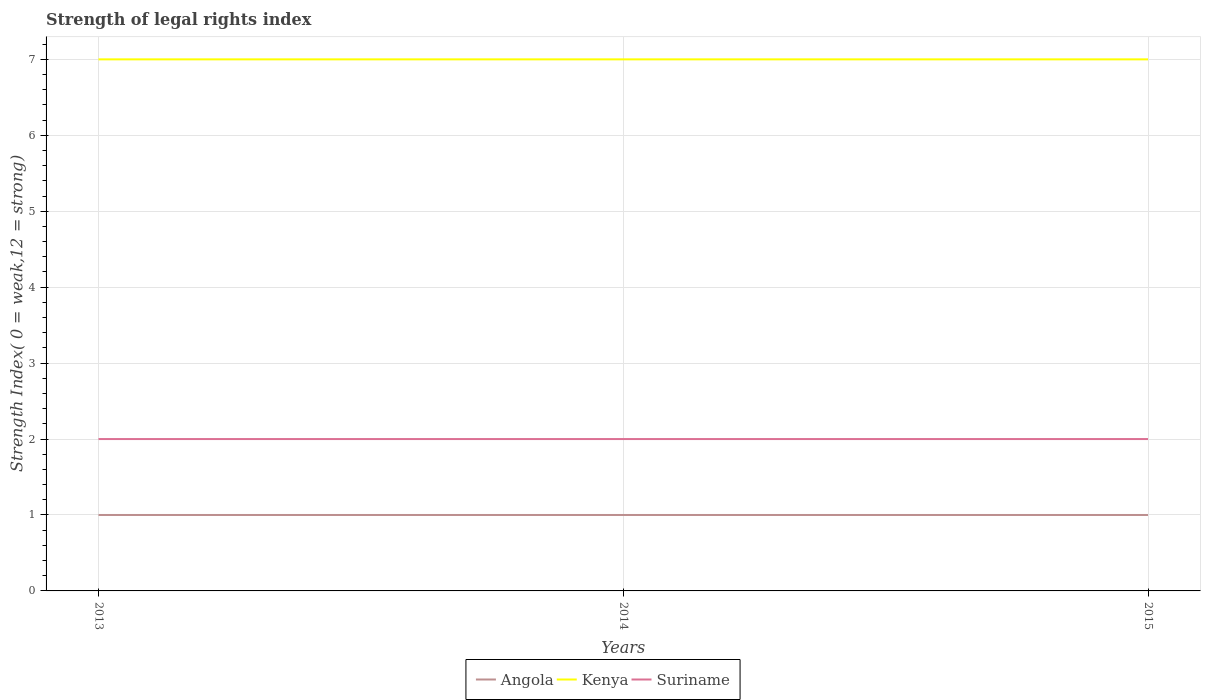How many different coloured lines are there?
Make the answer very short. 3. Does the line corresponding to Kenya intersect with the line corresponding to Suriname?
Keep it short and to the point. No. Across all years, what is the maximum strength index in Kenya?
Ensure brevity in your answer.  7. What is the total strength index in Kenya in the graph?
Make the answer very short. 0. Are the values on the major ticks of Y-axis written in scientific E-notation?
Your response must be concise. No. How many legend labels are there?
Provide a short and direct response. 3. How are the legend labels stacked?
Offer a very short reply. Horizontal. What is the title of the graph?
Your answer should be very brief. Strength of legal rights index. Does "Pakistan" appear as one of the legend labels in the graph?
Provide a succinct answer. No. What is the label or title of the X-axis?
Offer a very short reply. Years. What is the label or title of the Y-axis?
Provide a short and direct response. Strength Index( 0 = weak,12 = strong). What is the Strength Index( 0 = weak,12 = strong) in Kenya in 2013?
Offer a terse response. 7. What is the Strength Index( 0 = weak,12 = strong) of Suriname in 2013?
Ensure brevity in your answer.  2. What is the Strength Index( 0 = weak,12 = strong) in Angola in 2014?
Offer a terse response. 1. What is the Strength Index( 0 = weak,12 = strong) of Kenya in 2014?
Provide a succinct answer. 7. What is the Strength Index( 0 = weak,12 = strong) in Angola in 2015?
Provide a succinct answer. 1. What is the Strength Index( 0 = weak,12 = strong) in Kenya in 2015?
Offer a terse response. 7. Across all years, what is the maximum Strength Index( 0 = weak,12 = strong) in Angola?
Provide a succinct answer. 1. Across all years, what is the maximum Strength Index( 0 = weak,12 = strong) of Kenya?
Provide a succinct answer. 7. Across all years, what is the maximum Strength Index( 0 = weak,12 = strong) of Suriname?
Your answer should be very brief. 2. What is the total Strength Index( 0 = weak,12 = strong) in Angola in the graph?
Ensure brevity in your answer.  3. What is the total Strength Index( 0 = weak,12 = strong) of Kenya in the graph?
Ensure brevity in your answer.  21. What is the total Strength Index( 0 = weak,12 = strong) in Suriname in the graph?
Ensure brevity in your answer.  6. What is the difference between the Strength Index( 0 = weak,12 = strong) in Kenya in 2013 and that in 2014?
Give a very brief answer. 0. What is the difference between the Strength Index( 0 = weak,12 = strong) in Suriname in 2013 and that in 2014?
Keep it short and to the point. 0. What is the difference between the Strength Index( 0 = weak,12 = strong) of Suriname in 2013 and that in 2015?
Offer a terse response. 0. What is the difference between the Strength Index( 0 = weak,12 = strong) of Angola in 2013 and the Strength Index( 0 = weak,12 = strong) of Kenya in 2014?
Provide a short and direct response. -6. What is the difference between the Strength Index( 0 = weak,12 = strong) in Angola in 2014 and the Strength Index( 0 = weak,12 = strong) in Suriname in 2015?
Provide a short and direct response. -1. What is the difference between the Strength Index( 0 = weak,12 = strong) of Kenya in 2014 and the Strength Index( 0 = weak,12 = strong) of Suriname in 2015?
Your answer should be compact. 5. What is the average Strength Index( 0 = weak,12 = strong) in Kenya per year?
Your answer should be compact. 7. In the year 2013, what is the difference between the Strength Index( 0 = weak,12 = strong) in Angola and Strength Index( 0 = weak,12 = strong) in Kenya?
Provide a succinct answer. -6. In the year 2013, what is the difference between the Strength Index( 0 = weak,12 = strong) of Kenya and Strength Index( 0 = weak,12 = strong) of Suriname?
Provide a succinct answer. 5. In the year 2014, what is the difference between the Strength Index( 0 = weak,12 = strong) of Angola and Strength Index( 0 = weak,12 = strong) of Kenya?
Make the answer very short. -6. In the year 2014, what is the difference between the Strength Index( 0 = weak,12 = strong) in Angola and Strength Index( 0 = weak,12 = strong) in Suriname?
Ensure brevity in your answer.  -1. In the year 2015, what is the difference between the Strength Index( 0 = weak,12 = strong) in Angola and Strength Index( 0 = weak,12 = strong) in Kenya?
Keep it short and to the point. -6. What is the ratio of the Strength Index( 0 = weak,12 = strong) in Suriname in 2013 to that in 2014?
Your answer should be compact. 1. What is the ratio of the Strength Index( 0 = weak,12 = strong) in Suriname in 2013 to that in 2015?
Your response must be concise. 1. What is the ratio of the Strength Index( 0 = weak,12 = strong) in Kenya in 2014 to that in 2015?
Your answer should be compact. 1. What is the difference between the highest and the second highest Strength Index( 0 = weak,12 = strong) in Angola?
Give a very brief answer. 0. What is the difference between the highest and the lowest Strength Index( 0 = weak,12 = strong) of Kenya?
Give a very brief answer. 0. What is the difference between the highest and the lowest Strength Index( 0 = weak,12 = strong) of Suriname?
Provide a short and direct response. 0. 